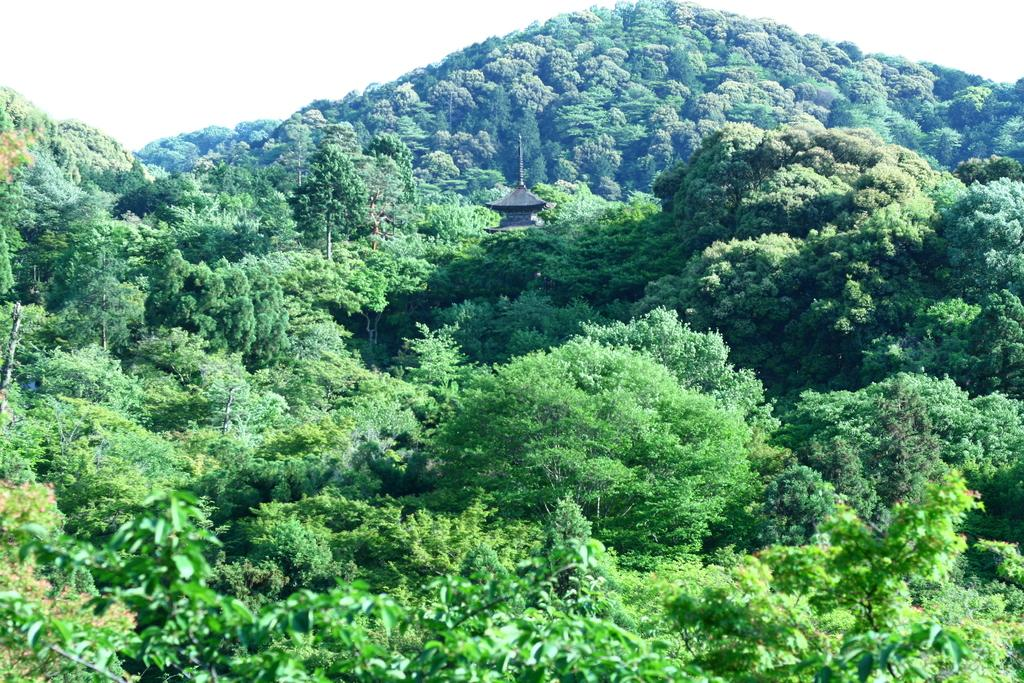What type of vegetation is present in the image? There are trees with branches and leaves in the image. What geographical feature can be seen in the image? The image appears to depict a hill. What type of structure is present in the image? There is a building with a spire in the image. Where is the building located in relation to the trees? The building is situated between the trees. Can you describe the truck that is parked on the hill in the image? There is no truck present in the image; it only features trees, a hill, and a building with a spire. 